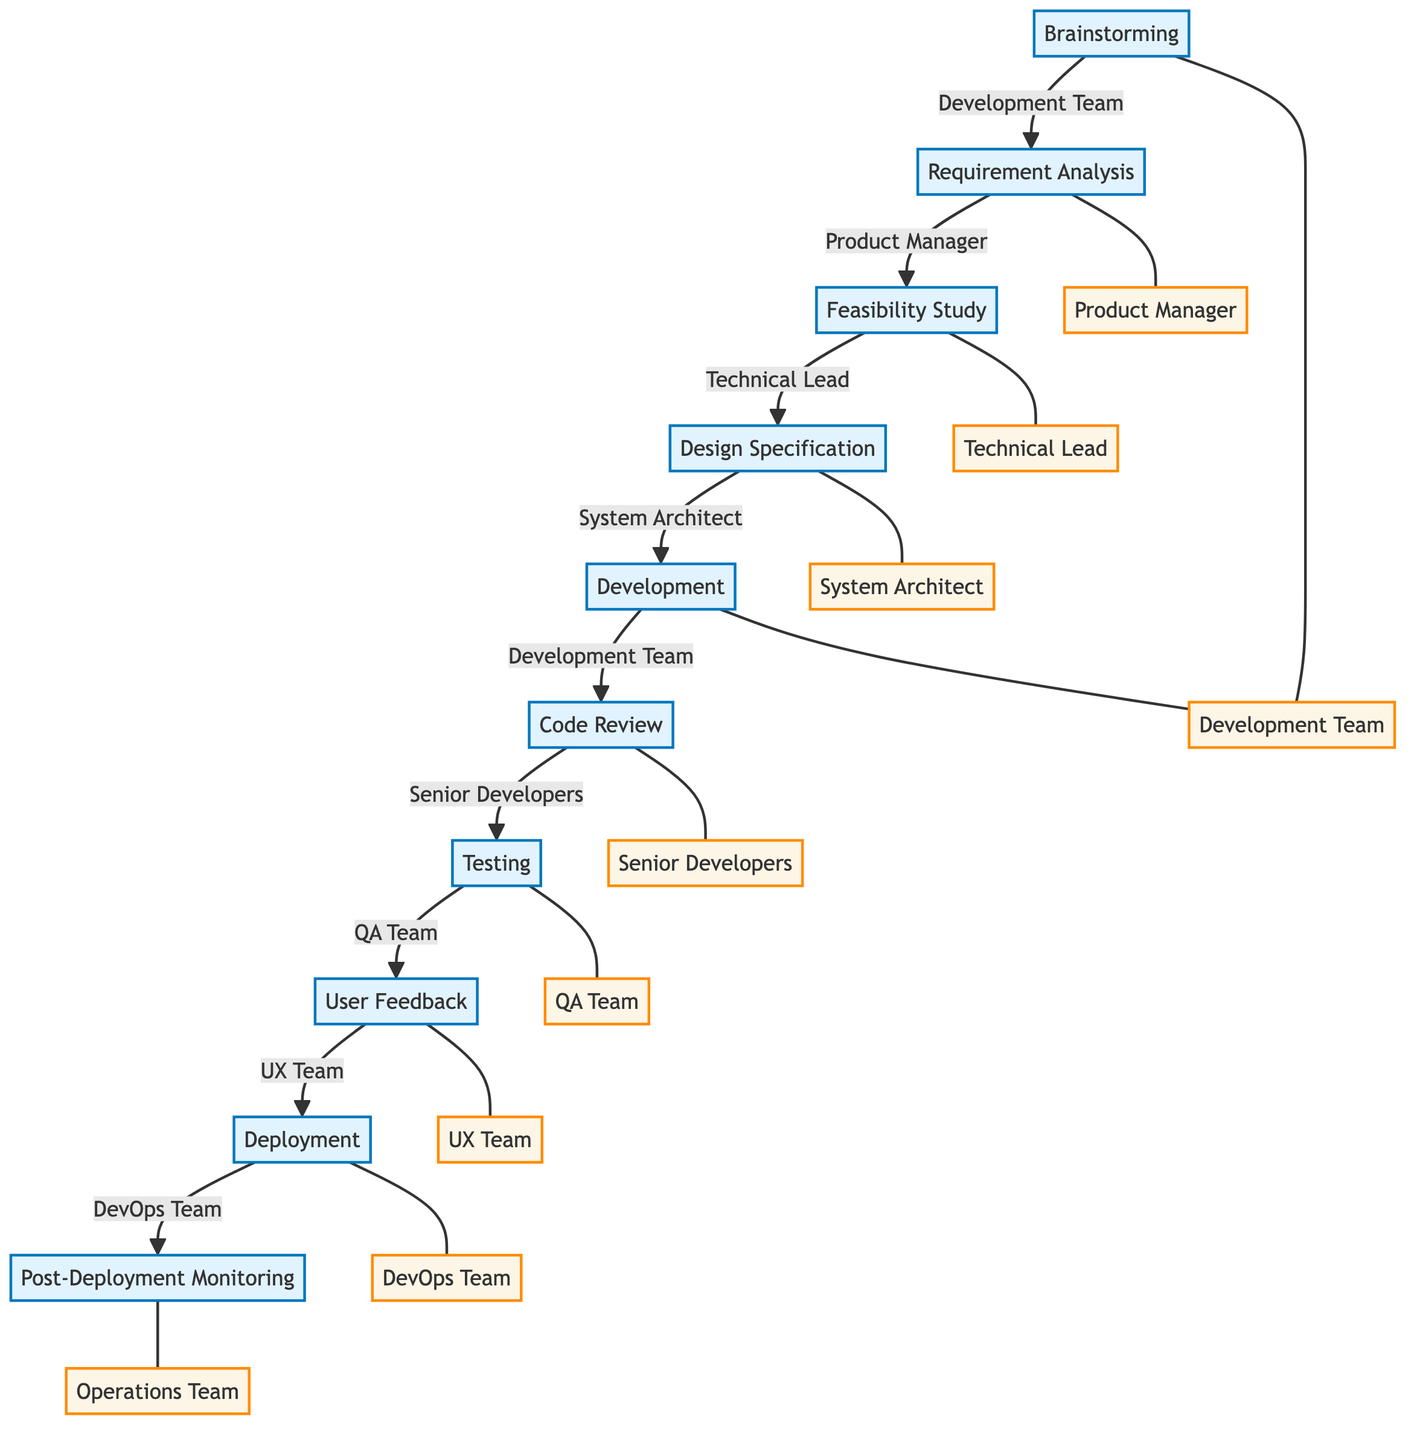What is the first step in the process? The first step in the flow chart is labeled as "Brainstorming," indicating that this is where the feature idea generation begins.
Answer: Brainstorming Who is responsible for Requirement Analysis? The flow chart specifies that the Product Manager is responsible for collecting requirements once the brainstorming session is completed.
Answer: Product Manager How many total steps are there in the diagram? By counting the number of distinct steps listed from start to finish, there are a total of ten steps in the implementation process.
Answer: Ten What comes after Code Review? The flow chart shows that after the Code Review step, the next step is Testing, indicating the sequence of activities that follow code validation.
Answer: Testing Which team is involved in both Development and Code Review? The Development Team is seen both in the Development step, where they implement the feature, and again during the Code Review step, where the code they wrote is reviewed.
Answer: Development Team What is the last step in the process? Referring to the flow chart, the last step concludes with Post-Deployment Monitoring, which involves monitoring the feature's performance after it has been deployed.
Answer: Post-Deployment Monitoring Which step involves gathering user feedback? The diagram indicates that User Feedback is specifically gathered after the Testing phase, highlighting its importance in ensuring that the feature meets user needs.
Answer: User Feedback Which step follows Deployment? The next step that follows Deployment, as indicated in the flow, is Post-Deployment Monitoring, focusing on the feature’s ongoing performance.
Answer: Post-Deployment Monitoring Who is responsible for the Testing phase? The QA Team is designated as responsible for carrying out various testing methods as part of the development process.
Answer: QA Team 